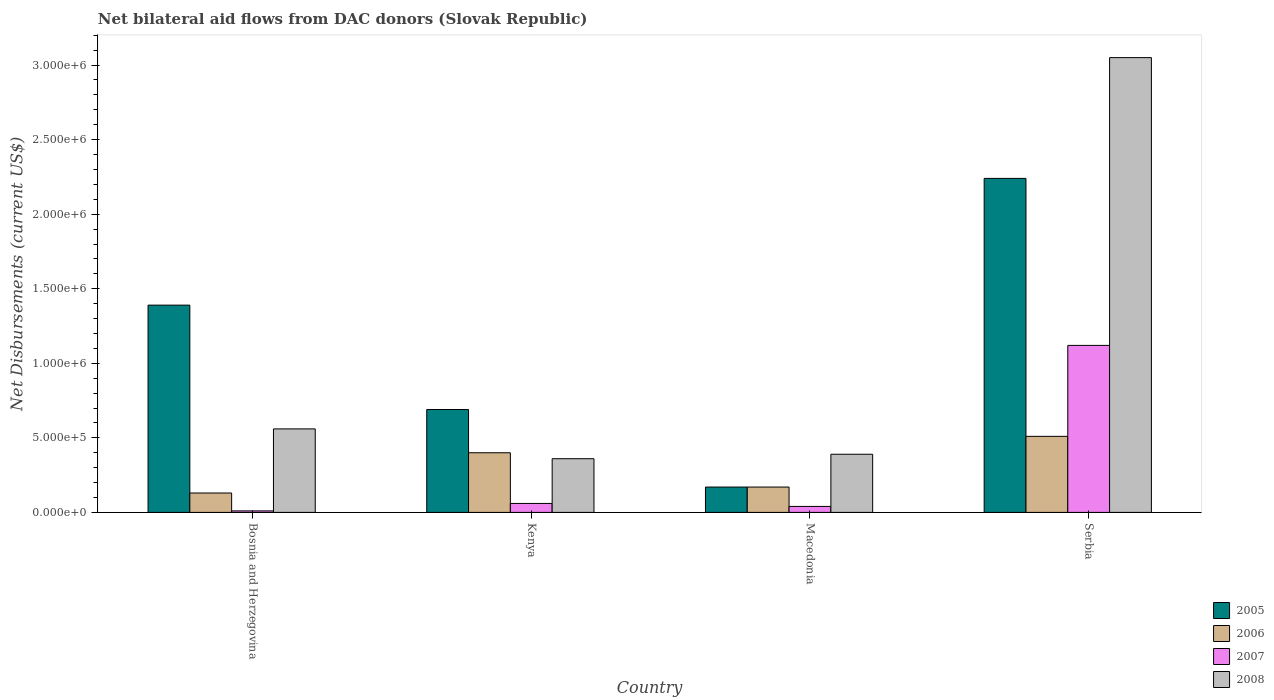How many different coloured bars are there?
Ensure brevity in your answer.  4. Are the number of bars per tick equal to the number of legend labels?
Ensure brevity in your answer.  Yes. How many bars are there on the 2nd tick from the right?
Ensure brevity in your answer.  4. What is the label of the 3rd group of bars from the left?
Offer a terse response. Macedonia. What is the net bilateral aid flows in 2005 in Kenya?
Make the answer very short. 6.90e+05. Across all countries, what is the maximum net bilateral aid flows in 2007?
Offer a terse response. 1.12e+06. In which country was the net bilateral aid flows in 2008 maximum?
Keep it short and to the point. Serbia. In which country was the net bilateral aid flows in 2007 minimum?
Your answer should be compact. Bosnia and Herzegovina. What is the total net bilateral aid flows in 2008 in the graph?
Provide a short and direct response. 4.36e+06. What is the difference between the net bilateral aid flows in 2006 in Bosnia and Herzegovina and that in Kenya?
Keep it short and to the point. -2.70e+05. What is the difference between the net bilateral aid flows in 2006 in Bosnia and Herzegovina and the net bilateral aid flows in 2008 in Serbia?
Ensure brevity in your answer.  -2.92e+06. What is the average net bilateral aid flows in 2006 per country?
Ensure brevity in your answer.  3.02e+05. What is the difference between the net bilateral aid flows of/in 2008 and net bilateral aid flows of/in 2005 in Kenya?
Provide a succinct answer. -3.30e+05. What is the ratio of the net bilateral aid flows in 2008 in Kenya to that in Macedonia?
Keep it short and to the point. 0.92. Is the difference between the net bilateral aid flows in 2008 in Bosnia and Herzegovina and Serbia greater than the difference between the net bilateral aid flows in 2005 in Bosnia and Herzegovina and Serbia?
Provide a short and direct response. No. What is the difference between the highest and the second highest net bilateral aid flows in 2005?
Offer a very short reply. 1.55e+06. What is the difference between the highest and the lowest net bilateral aid flows in 2007?
Your answer should be compact. 1.11e+06. Is it the case that in every country, the sum of the net bilateral aid flows in 2008 and net bilateral aid flows in 2007 is greater than the sum of net bilateral aid flows in 2005 and net bilateral aid flows in 2006?
Offer a very short reply. No. What does the 3rd bar from the left in Kenya represents?
Your response must be concise. 2007. What does the 1st bar from the right in Serbia represents?
Your answer should be very brief. 2008. How many bars are there?
Ensure brevity in your answer.  16. Are all the bars in the graph horizontal?
Offer a terse response. No. Are the values on the major ticks of Y-axis written in scientific E-notation?
Provide a succinct answer. Yes. Does the graph contain any zero values?
Provide a succinct answer. No. Does the graph contain grids?
Keep it short and to the point. No. Where does the legend appear in the graph?
Keep it short and to the point. Bottom right. How many legend labels are there?
Your response must be concise. 4. How are the legend labels stacked?
Offer a very short reply. Vertical. What is the title of the graph?
Your response must be concise. Net bilateral aid flows from DAC donors (Slovak Republic). Does "1990" appear as one of the legend labels in the graph?
Your answer should be compact. No. What is the label or title of the X-axis?
Offer a very short reply. Country. What is the label or title of the Y-axis?
Your response must be concise. Net Disbursements (current US$). What is the Net Disbursements (current US$) in 2005 in Bosnia and Herzegovina?
Ensure brevity in your answer.  1.39e+06. What is the Net Disbursements (current US$) of 2006 in Bosnia and Herzegovina?
Make the answer very short. 1.30e+05. What is the Net Disbursements (current US$) in 2007 in Bosnia and Herzegovina?
Provide a short and direct response. 10000. What is the Net Disbursements (current US$) of 2008 in Bosnia and Herzegovina?
Your response must be concise. 5.60e+05. What is the Net Disbursements (current US$) of 2005 in Kenya?
Offer a terse response. 6.90e+05. What is the Net Disbursements (current US$) of 2006 in Kenya?
Offer a terse response. 4.00e+05. What is the Net Disbursements (current US$) in 2008 in Kenya?
Make the answer very short. 3.60e+05. What is the Net Disbursements (current US$) of 2005 in Macedonia?
Your response must be concise. 1.70e+05. What is the Net Disbursements (current US$) of 2006 in Macedonia?
Offer a very short reply. 1.70e+05. What is the Net Disbursements (current US$) in 2007 in Macedonia?
Your answer should be compact. 4.00e+04. What is the Net Disbursements (current US$) of 2005 in Serbia?
Ensure brevity in your answer.  2.24e+06. What is the Net Disbursements (current US$) of 2006 in Serbia?
Ensure brevity in your answer.  5.10e+05. What is the Net Disbursements (current US$) in 2007 in Serbia?
Provide a short and direct response. 1.12e+06. What is the Net Disbursements (current US$) of 2008 in Serbia?
Provide a short and direct response. 3.05e+06. Across all countries, what is the maximum Net Disbursements (current US$) of 2005?
Ensure brevity in your answer.  2.24e+06. Across all countries, what is the maximum Net Disbursements (current US$) of 2006?
Give a very brief answer. 5.10e+05. Across all countries, what is the maximum Net Disbursements (current US$) in 2007?
Provide a succinct answer. 1.12e+06. Across all countries, what is the maximum Net Disbursements (current US$) in 2008?
Provide a short and direct response. 3.05e+06. Across all countries, what is the minimum Net Disbursements (current US$) of 2006?
Provide a succinct answer. 1.30e+05. Across all countries, what is the minimum Net Disbursements (current US$) of 2007?
Keep it short and to the point. 10000. Across all countries, what is the minimum Net Disbursements (current US$) of 2008?
Your response must be concise. 3.60e+05. What is the total Net Disbursements (current US$) in 2005 in the graph?
Your answer should be compact. 4.49e+06. What is the total Net Disbursements (current US$) in 2006 in the graph?
Give a very brief answer. 1.21e+06. What is the total Net Disbursements (current US$) of 2007 in the graph?
Keep it short and to the point. 1.23e+06. What is the total Net Disbursements (current US$) of 2008 in the graph?
Your answer should be very brief. 4.36e+06. What is the difference between the Net Disbursements (current US$) of 2008 in Bosnia and Herzegovina and that in Kenya?
Your answer should be compact. 2.00e+05. What is the difference between the Net Disbursements (current US$) of 2005 in Bosnia and Herzegovina and that in Macedonia?
Your response must be concise. 1.22e+06. What is the difference between the Net Disbursements (current US$) in 2008 in Bosnia and Herzegovina and that in Macedonia?
Give a very brief answer. 1.70e+05. What is the difference between the Net Disbursements (current US$) in 2005 in Bosnia and Herzegovina and that in Serbia?
Your response must be concise. -8.50e+05. What is the difference between the Net Disbursements (current US$) of 2006 in Bosnia and Herzegovina and that in Serbia?
Make the answer very short. -3.80e+05. What is the difference between the Net Disbursements (current US$) of 2007 in Bosnia and Herzegovina and that in Serbia?
Your answer should be very brief. -1.11e+06. What is the difference between the Net Disbursements (current US$) of 2008 in Bosnia and Herzegovina and that in Serbia?
Offer a terse response. -2.49e+06. What is the difference between the Net Disbursements (current US$) in 2005 in Kenya and that in Macedonia?
Offer a very short reply. 5.20e+05. What is the difference between the Net Disbursements (current US$) in 2005 in Kenya and that in Serbia?
Make the answer very short. -1.55e+06. What is the difference between the Net Disbursements (current US$) of 2007 in Kenya and that in Serbia?
Ensure brevity in your answer.  -1.06e+06. What is the difference between the Net Disbursements (current US$) in 2008 in Kenya and that in Serbia?
Keep it short and to the point. -2.69e+06. What is the difference between the Net Disbursements (current US$) of 2005 in Macedonia and that in Serbia?
Provide a short and direct response. -2.07e+06. What is the difference between the Net Disbursements (current US$) in 2007 in Macedonia and that in Serbia?
Make the answer very short. -1.08e+06. What is the difference between the Net Disbursements (current US$) in 2008 in Macedonia and that in Serbia?
Keep it short and to the point. -2.66e+06. What is the difference between the Net Disbursements (current US$) of 2005 in Bosnia and Herzegovina and the Net Disbursements (current US$) of 2006 in Kenya?
Make the answer very short. 9.90e+05. What is the difference between the Net Disbursements (current US$) of 2005 in Bosnia and Herzegovina and the Net Disbursements (current US$) of 2007 in Kenya?
Provide a succinct answer. 1.33e+06. What is the difference between the Net Disbursements (current US$) of 2005 in Bosnia and Herzegovina and the Net Disbursements (current US$) of 2008 in Kenya?
Offer a terse response. 1.03e+06. What is the difference between the Net Disbursements (current US$) in 2006 in Bosnia and Herzegovina and the Net Disbursements (current US$) in 2007 in Kenya?
Give a very brief answer. 7.00e+04. What is the difference between the Net Disbursements (current US$) in 2007 in Bosnia and Herzegovina and the Net Disbursements (current US$) in 2008 in Kenya?
Your answer should be compact. -3.50e+05. What is the difference between the Net Disbursements (current US$) in 2005 in Bosnia and Herzegovina and the Net Disbursements (current US$) in 2006 in Macedonia?
Your response must be concise. 1.22e+06. What is the difference between the Net Disbursements (current US$) of 2005 in Bosnia and Herzegovina and the Net Disbursements (current US$) of 2007 in Macedonia?
Offer a very short reply. 1.35e+06. What is the difference between the Net Disbursements (current US$) of 2006 in Bosnia and Herzegovina and the Net Disbursements (current US$) of 2007 in Macedonia?
Your response must be concise. 9.00e+04. What is the difference between the Net Disbursements (current US$) in 2006 in Bosnia and Herzegovina and the Net Disbursements (current US$) in 2008 in Macedonia?
Keep it short and to the point. -2.60e+05. What is the difference between the Net Disbursements (current US$) in 2007 in Bosnia and Herzegovina and the Net Disbursements (current US$) in 2008 in Macedonia?
Offer a very short reply. -3.80e+05. What is the difference between the Net Disbursements (current US$) of 2005 in Bosnia and Herzegovina and the Net Disbursements (current US$) of 2006 in Serbia?
Offer a terse response. 8.80e+05. What is the difference between the Net Disbursements (current US$) of 2005 in Bosnia and Herzegovina and the Net Disbursements (current US$) of 2007 in Serbia?
Your answer should be compact. 2.70e+05. What is the difference between the Net Disbursements (current US$) of 2005 in Bosnia and Herzegovina and the Net Disbursements (current US$) of 2008 in Serbia?
Keep it short and to the point. -1.66e+06. What is the difference between the Net Disbursements (current US$) in 2006 in Bosnia and Herzegovina and the Net Disbursements (current US$) in 2007 in Serbia?
Offer a terse response. -9.90e+05. What is the difference between the Net Disbursements (current US$) in 2006 in Bosnia and Herzegovina and the Net Disbursements (current US$) in 2008 in Serbia?
Make the answer very short. -2.92e+06. What is the difference between the Net Disbursements (current US$) in 2007 in Bosnia and Herzegovina and the Net Disbursements (current US$) in 2008 in Serbia?
Provide a short and direct response. -3.04e+06. What is the difference between the Net Disbursements (current US$) in 2005 in Kenya and the Net Disbursements (current US$) in 2006 in Macedonia?
Give a very brief answer. 5.20e+05. What is the difference between the Net Disbursements (current US$) of 2005 in Kenya and the Net Disbursements (current US$) of 2007 in Macedonia?
Offer a very short reply. 6.50e+05. What is the difference between the Net Disbursements (current US$) of 2006 in Kenya and the Net Disbursements (current US$) of 2007 in Macedonia?
Make the answer very short. 3.60e+05. What is the difference between the Net Disbursements (current US$) in 2007 in Kenya and the Net Disbursements (current US$) in 2008 in Macedonia?
Provide a succinct answer. -3.30e+05. What is the difference between the Net Disbursements (current US$) in 2005 in Kenya and the Net Disbursements (current US$) in 2006 in Serbia?
Make the answer very short. 1.80e+05. What is the difference between the Net Disbursements (current US$) in 2005 in Kenya and the Net Disbursements (current US$) in 2007 in Serbia?
Ensure brevity in your answer.  -4.30e+05. What is the difference between the Net Disbursements (current US$) of 2005 in Kenya and the Net Disbursements (current US$) of 2008 in Serbia?
Keep it short and to the point. -2.36e+06. What is the difference between the Net Disbursements (current US$) of 2006 in Kenya and the Net Disbursements (current US$) of 2007 in Serbia?
Provide a succinct answer. -7.20e+05. What is the difference between the Net Disbursements (current US$) of 2006 in Kenya and the Net Disbursements (current US$) of 2008 in Serbia?
Keep it short and to the point. -2.65e+06. What is the difference between the Net Disbursements (current US$) in 2007 in Kenya and the Net Disbursements (current US$) in 2008 in Serbia?
Offer a terse response. -2.99e+06. What is the difference between the Net Disbursements (current US$) of 2005 in Macedonia and the Net Disbursements (current US$) of 2006 in Serbia?
Offer a terse response. -3.40e+05. What is the difference between the Net Disbursements (current US$) in 2005 in Macedonia and the Net Disbursements (current US$) in 2007 in Serbia?
Make the answer very short. -9.50e+05. What is the difference between the Net Disbursements (current US$) in 2005 in Macedonia and the Net Disbursements (current US$) in 2008 in Serbia?
Offer a terse response. -2.88e+06. What is the difference between the Net Disbursements (current US$) in 2006 in Macedonia and the Net Disbursements (current US$) in 2007 in Serbia?
Your response must be concise. -9.50e+05. What is the difference between the Net Disbursements (current US$) of 2006 in Macedonia and the Net Disbursements (current US$) of 2008 in Serbia?
Your answer should be very brief. -2.88e+06. What is the difference between the Net Disbursements (current US$) of 2007 in Macedonia and the Net Disbursements (current US$) of 2008 in Serbia?
Your response must be concise. -3.01e+06. What is the average Net Disbursements (current US$) of 2005 per country?
Offer a terse response. 1.12e+06. What is the average Net Disbursements (current US$) in 2006 per country?
Give a very brief answer. 3.02e+05. What is the average Net Disbursements (current US$) in 2007 per country?
Provide a succinct answer. 3.08e+05. What is the average Net Disbursements (current US$) of 2008 per country?
Your answer should be very brief. 1.09e+06. What is the difference between the Net Disbursements (current US$) in 2005 and Net Disbursements (current US$) in 2006 in Bosnia and Herzegovina?
Provide a short and direct response. 1.26e+06. What is the difference between the Net Disbursements (current US$) in 2005 and Net Disbursements (current US$) in 2007 in Bosnia and Herzegovina?
Keep it short and to the point. 1.38e+06. What is the difference between the Net Disbursements (current US$) in 2005 and Net Disbursements (current US$) in 2008 in Bosnia and Herzegovina?
Provide a succinct answer. 8.30e+05. What is the difference between the Net Disbursements (current US$) of 2006 and Net Disbursements (current US$) of 2007 in Bosnia and Herzegovina?
Offer a terse response. 1.20e+05. What is the difference between the Net Disbursements (current US$) of 2006 and Net Disbursements (current US$) of 2008 in Bosnia and Herzegovina?
Provide a succinct answer. -4.30e+05. What is the difference between the Net Disbursements (current US$) of 2007 and Net Disbursements (current US$) of 2008 in Bosnia and Herzegovina?
Keep it short and to the point. -5.50e+05. What is the difference between the Net Disbursements (current US$) in 2005 and Net Disbursements (current US$) in 2006 in Kenya?
Your answer should be very brief. 2.90e+05. What is the difference between the Net Disbursements (current US$) in 2005 and Net Disbursements (current US$) in 2007 in Kenya?
Ensure brevity in your answer.  6.30e+05. What is the difference between the Net Disbursements (current US$) in 2005 and Net Disbursements (current US$) in 2008 in Kenya?
Offer a terse response. 3.30e+05. What is the difference between the Net Disbursements (current US$) in 2006 and Net Disbursements (current US$) in 2007 in Kenya?
Provide a short and direct response. 3.40e+05. What is the difference between the Net Disbursements (current US$) in 2007 and Net Disbursements (current US$) in 2008 in Kenya?
Make the answer very short. -3.00e+05. What is the difference between the Net Disbursements (current US$) of 2005 and Net Disbursements (current US$) of 2006 in Macedonia?
Offer a terse response. 0. What is the difference between the Net Disbursements (current US$) in 2006 and Net Disbursements (current US$) in 2007 in Macedonia?
Make the answer very short. 1.30e+05. What is the difference between the Net Disbursements (current US$) in 2007 and Net Disbursements (current US$) in 2008 in Macedonia?
Keep it short and to the point. -3.50e+05. What is the difference between the Net Disbursements (current US$) in 2005 and Net Disbursements (current US$) in 2006 in Serbia?
Offer a very short reply. 1.73e+06. What is the difference between the Net Disbursements (current US$) in 2005 and Net Disbursements (current US$) in 2007 in Serbia?
Make the answer very short. 1.12e+06. What is the difference between the Net Disbursements (current US$) in 2005 and Net Disbursements (current US$) in 2008 in Serbia?
Offer a terse response. -8.10e+05. What is the difference between the Net Disbursements (current US$) of 2006 and Net Disbursements (current US$) of 2007 in Serbia?
Offer a terse response. -6.10e+05. What is the difference between the Net Disbursements (current US$) of 2006 and Net Disbursements (current US$) of 2008 in Serbia?
Keep it short and to the point. -2.54e+06. What is the difference between the Net Disbursements (current US$) of 2007 and Net Disbursements (current US$) of 2008 in Serbia?
Provide a succinct answer. -1.93e+06. What is the ratio of the Net Disbursements (current US$) in 2005 in Bosnia and Herzegovina to that in Kenya?
Ensure brevity in your answer.  2.01. What is the ratio of the Net Disbursements (current US$) of 2006 in Bosnia and Herzegovina to that in Kenya?
Your answer should be compact. 0.33. What is the ratio of the Net Disbursements (current US$) of 2008 in Bosnia and Herzegovina to that in Kenya?
Make the answer very short. 1.56. What is the ratio of the Net Disbursements (current US$) of 2005 in Bosnia and Herzegovina to that in Macedonia?
Offer a terse response. 8.18. What is the ratio of the Net Disbursements (current US$) in 2006 in Bosnia and Herzegovina to that in Macedonia?
Provide a succinct answer. 0.76. What is the ratio of the Net Disbursements (current US$) of 2007 in Bosnia and Herzegovina to that in Macedonia?
Your answer should be compact. 0.25. What is the ratio of the Net Disbursements (current US$) in 2008 in Bosnia and Herzegovina to that in Macedonia?
Offer a very short reply. 1.44. What is the ratio of the Net Disbursements (current US$) of 2005 in Bosnia and Herzegovina to that in Serbia?
Keep it short and to the point. 0.62. What is the ratio of the Net Disbursements (current US$) in 2006 in Bosnia and Herzegovina to that in Serbia?
Ensure brevity in your answer.  0.25. What is the ratio of the Net Disbursements (current US$) of 2007 in Bosnia and Herzegovina to that in Serbia?
Offer a terse response. 0.01. What is the ratio of the Net Disbursements (current US$) in 2008 in Bosnia and Herzegovina to that in Serbia?
Your response must be concise. 0.18. What is the ratio of the Net Disbursements (current US$) in 2005 in Kenya to that in Macedonia?
Your answer should be very brief. 4.06. What is the ratio of the Net Disbursements (current US$) of 2006 in Kenya to that in Macedonia?
Your response must be concise. 2.35. What is the ratio of the Net Disbursements (current US$) in 2005 in Kenya to that in Serbia?
Your response must be concise. 0.31. What is the ratio of the Net Disbursements (current US$) of 2006 in Kenya to that in Serbia?
Offer a terse response. 0.78. What is the ratio of the Net Disbursements (current US$) in 2007 in Kenya to that in Serbia?
Your response must be concise. 0.05. What is the ratio of the Net Disbursements (current US$) in 2008 in Kenya to that in Serbia?
Make the answer very short. 0.12. What is the ratio of the Net Disbursements (current US$) in 2005 in Macedonia to that in Serbia?
Offer a terse response. 0.08. What is the ratio of the Net Disbursements (current US$) in 2006 in Macedonia to that in Serbia?
Your answer should be very brief. 0.33. What is the ratio of the Net Disbursements (current US$) of 2007 in Macedonia to that in Serbia?
Your response must be concise. 0.04. What is the ratio of the Net Disbursements (current US$) in 2008 in Macedonia to that in Serbia?
Offer a very short reply. 0.13. What is the difference between the highest and the second highest Net Disbursements (current US$) in 2005?
Keep it short and to the point. 8.50e+05. What is the difference between the highest and the second highest Net Disbursements (current US$) in 2007?
Your answer should be compact. 1.06e+06. What is the difference between the highest and the second highest Net Disbursements (current US$) in 2008?
Offer a terse response. 2.49e+06. What is the difference between the highest and the lowest Net Disbursements (current US$) in 2005?
Provide a succinct answer. 2.07e+06. What is the difference between the highest and the lowest Net Disbursements (current US$) of 2007?
Provide a succinct answer. 1.11e+06. What is the difference between the highest and the lowest Net Disbursements (current US$) of 2008?
Provide a short and direct response. 2.69e+06. 